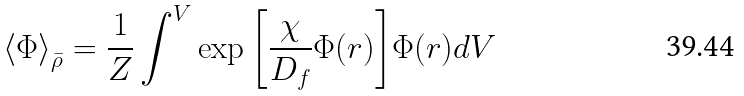<formula> <loc_0><loc_0><loc_500><loc_500>\left \langle \Phi \right \rangle _ { \bar { \rho } } = \frac { 1 } { Z } \int ^ { V } \exp { \left [ \frac { \chi } { D _ { f } } \Phi ( r ) \right ] } \Phi ( r ) d V</formula> 